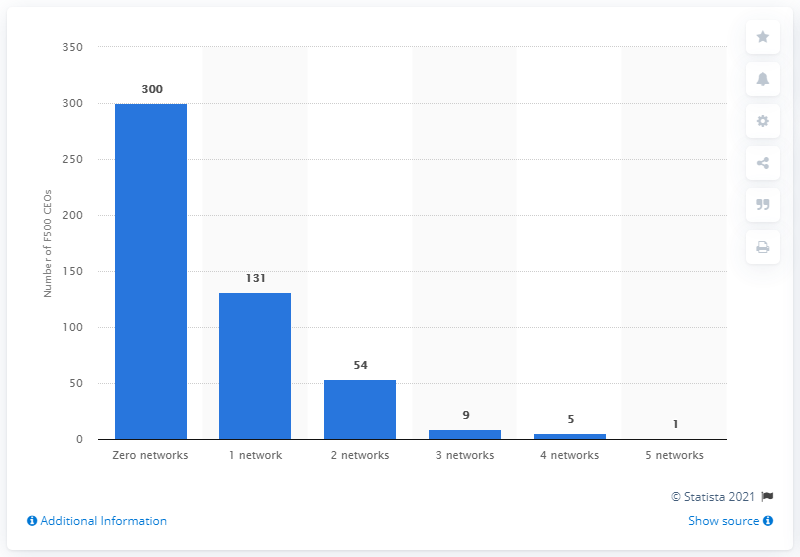How many CEOs had only one social media account? According to the chart, there were 131 CEOs who had only one social media account. This number is substantially lower than the 300 CEOs that are not present on social networks at all, suggesting that while some CEOs maintain a minimal online presence, a significant majority either fully embrace multiple social platforms or opt to abstain entirely. 